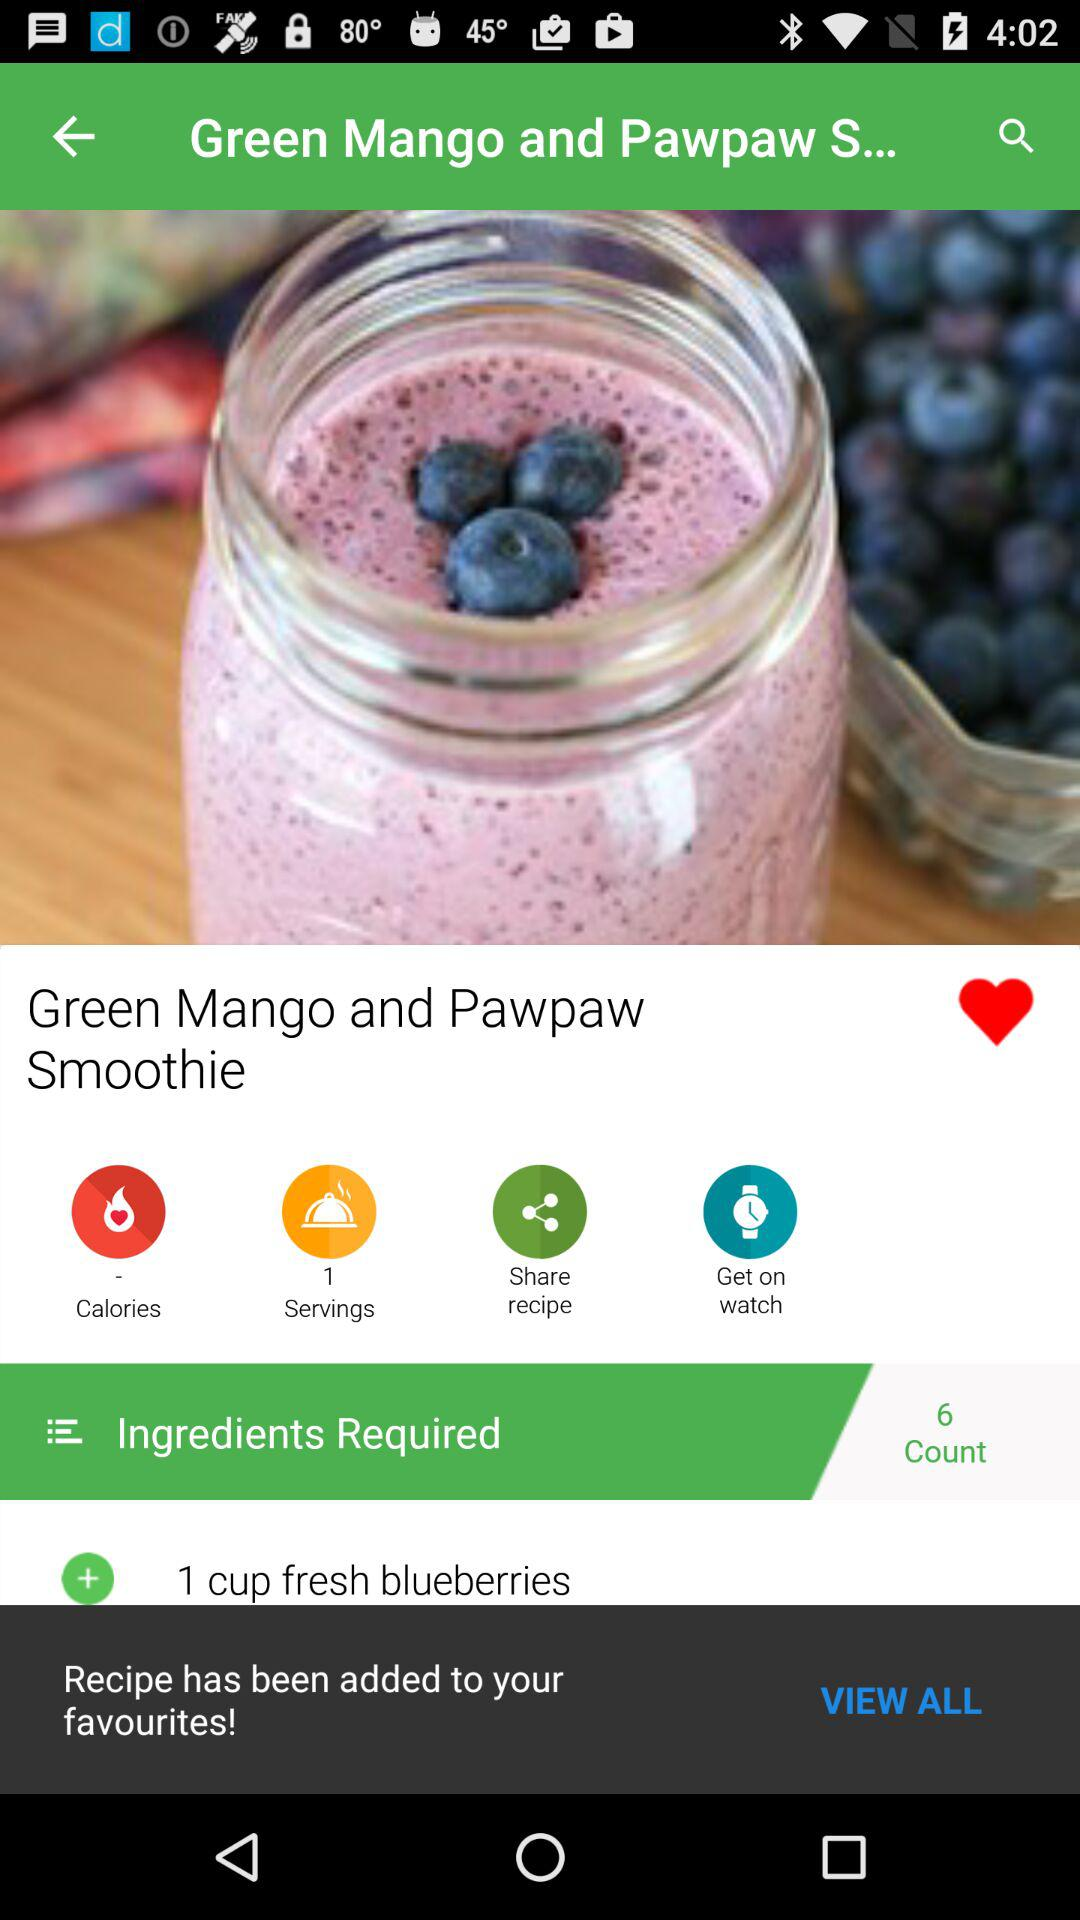To how many people can the "Green Mango and Pawpaw Smoothie" be served? The "Green Mango and Pawpaw Smoothie" can be served to 1 person. 